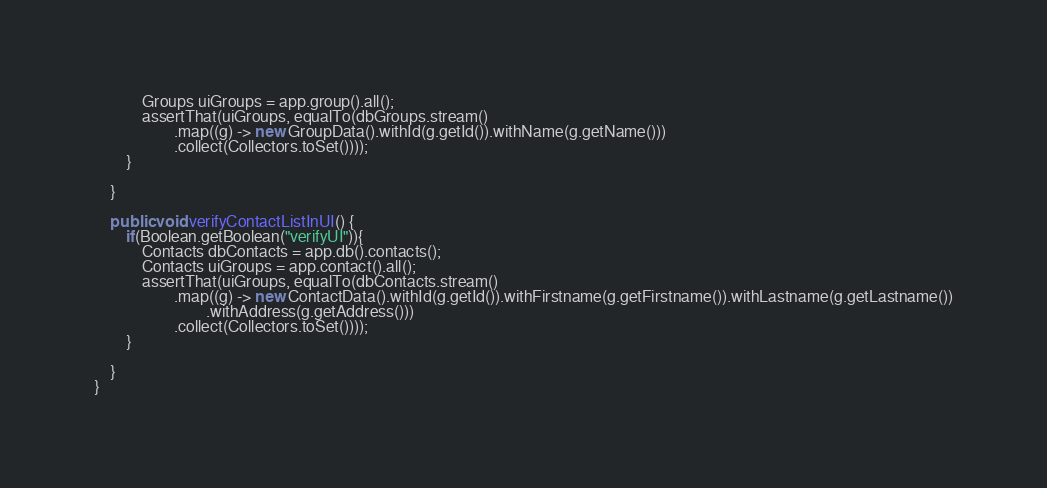Convert code to text. <code><loc_0><loc_0><loc_500><loc_500><_Java_>            Groups uiGroups = app.group().all();
            assertThat(uiGroups, equalTo(dbGroups.stream()
                    .map((g) -> new GroupData().withId(g.getId()).withName(g.getName()))
                    .collect(Collectors.toSet())));
        }

    }

    public void verifyContactListInUI() {
        if(Boolean.getBoolean("verifyUI")){
            Contacts dbContacts = app.db().contacts();
            Contacts uiGroups = app.contact().all();
            assertThat(uiGroups, equalTo(dbContacts.stream()
                    .map((g) -> new ContactData().withId(g.getId()).withFirstname(g.getFirstname()).withLastname(g.getLastname())
                            .withAddress(g.getAddress()))
                    .collect(Collectors.toSet())));
        }

    }
}
</code> 